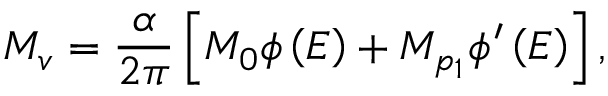<formula> <loc_0><loc_0><loc_500><loc_500>M _ { v } = \frac { \alpha } { 2 \pi } \left [ M _ { 0 } \phi \left ( E \right ) + M _ { p _ { 1 } } \phi ^ { \prime } \left ( E \right ) \right ] ,</formula> 